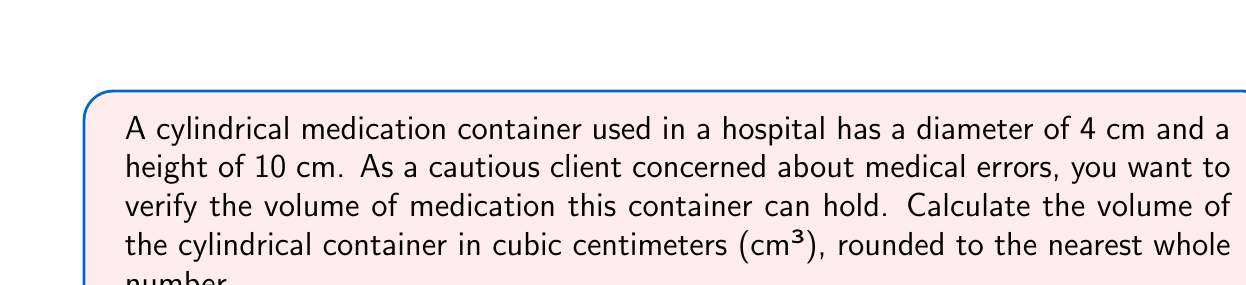Can you solve this math problem? To calculate the volume of a cylindrical container, we use the formula:

$$V = \pi r^2 h$$

Where:
$V$ = volume
$r$ = radius of the base
$h$ = height of the cylinder

Given:
- Diameter = 4 cm
- Height = 10 cm

Step 1: Calculate the radius
The radius is half the diameter:
$r = \frac{4}{2} = 2$ cm

Step 2: Apply the volume formula
$$V = \pi r^2 h$$
$$V = \pi (2\text{ cm})^2 (10\text{ cm})$$
$$V = \pi (4\text{ cm}^2) (10\text{ cm})$$
$$V = 40\pi\text{ cm}^3$$

Step 3: Calculate the final value
$$V = 40 \times 3.14159... \text{ cm}^3$$
$$V \approx 125.66\text{ cm}^3$$

Step 4: Round to the nearest whole number
$$V \approx 126\text{ cm}^3$$
Answer: 126 cm³ 